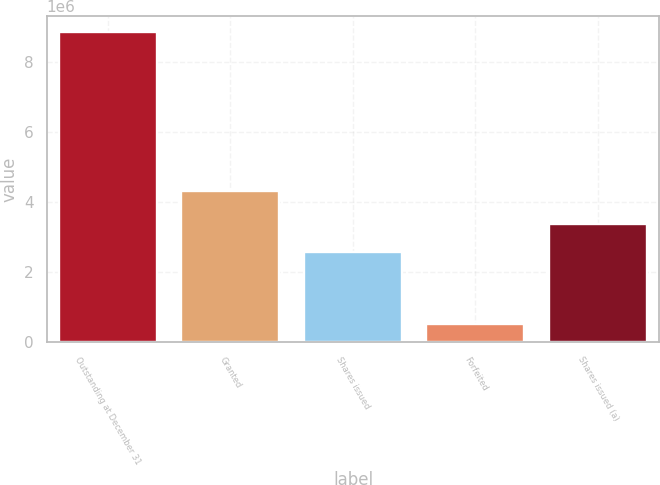Convert chart. <chart><loc_0><loc_0><loc_500><loc_500><bar_chart><fcel>Outstanding at December 31<fcel>Granted<fcel>Shares issued<fcel>Forfeited<fcel>Shares issued (a)<nl><fcel>8.87605e+06<fcel>4.31438e+06<fcel>2.56597e+06<fcel>500940<fcel>3.38196e+06<nl></chart> 